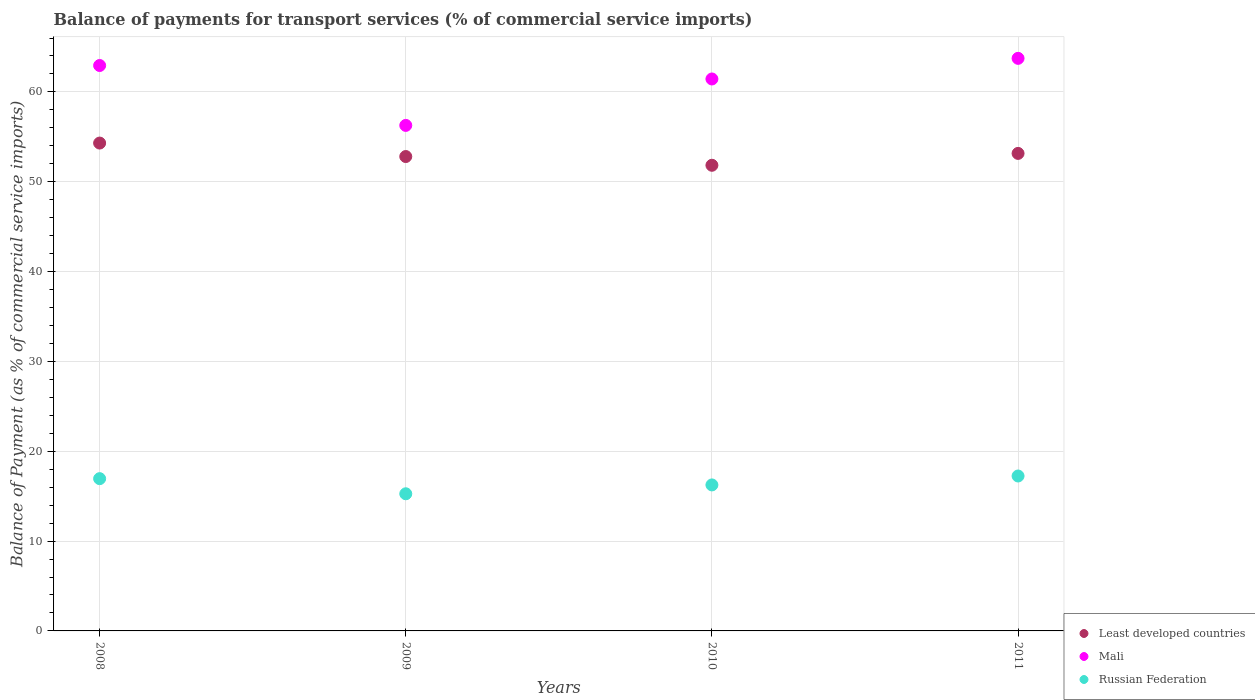What is the balance of payments for transport services in Mali in 2008?
Your answer should be compact. 62.94. Across all years, what is the maximum balance of payments for transport services in Mali?
Make the answer very short. 63.74. Across all years, what is the minimum balance of payments for transport services in Mali?
Keep it short and to the point. 56.27. In which year was the balance of payments for transport services in Mali minimum?
Offer a very short reply. 2009. What is the total balance of payments for transport services in Least developed countries in the graph?
Provide a short and direct response. 212.1. What is the difference between the balance of payments for transport services in Mali in 2010 and that in 2011?
Give a very brief answer. -2.3. What is the difference between the balance of payments for transport services in Least developed countries in 2010 and the balance of payments for transport services in Russian Federation in 2009?
Your answer should be compact. 36.57. What is the average balance of payments for transport services in Mali per year?
Offer a terse response. 61.1. In the year 2011, what is the difference between the balance of payments for transport services in Mali and balance of payments for transport services in Least developed countries?
Keep it short and to the point. 10.58. In how many years, is the balance of payments for transport services in Russian Federation greater than 60 %?
Your answer should be compact. 0. What is the ratio of the balance of payments for transport services in Mali in 2008 to that in 2011?
Give a very brief answer. 0.99. Is the balance of payments for transport services in Least developed countries in 2008 less than that in 2009?
Your response must be concise. No. What is the difference between the highest and the second highest balance of payments for transport services in Russian Federation?
Provide a short and direct response. 0.3. What is the difference between the highest and the lowest balance of payments for transport services in Russian Federation?
Give a very brief answer. 1.98. Is it the case that in every year, the sum of the balance of payments for transport services in Least developed countries and balance of payments for transport services in Russian Federation  is greater than the balance of payments for transport services in Mali?
Keep it short and to the point. Yes. Does the balance of payments for transport services in Least developed countries monotonically increase over the years?
Your answer should be very brief. No. Is the balance of payments for transport services in Least developed countries strictly greater than the balance of payments for transport services in Russian Federation over the years?
Your answer should be compact. Yes. How many dotlines are there?
Provide a short and direct response. 3. What is the difference between two consecutive major ticks on the Y-axis?
Your answer should be compact. 10. Are the values on the major ticks of Y-axis written in scientific E-notation?
Your answer should be compact. No. Does the graph contain any zero values?
Offer a terse response. No. Does the graph contain grids?
Your answer should be compact. Yes. How many legend labels are there?
Ensure brevity in your answer.  3. How are the legend labels stacked?
Offer a terse response. Vertical. What is the title of the graph?
Ensure brevity in your answer.  Balance of payments for transport services (% of commercial service imports). Does "Cayman Islands" appear as one of the legend labels in the graph?
Ensure brevity in your answer.  No. What is the label or title of the Y-axis?
Your answer should be compact. Balance of Payment (as % of commercial service imports). What is the Balance of Payment (as % of commercial service imports) of Least developed countries in 2008?
Your answer should be compact. 54.3. What is the Balance of Payment (as % of commercial service imports) in Mali in 2008?
Provide a short and direct response. 62.94. What is the Balance of Payment (as % of commercial service imports) of Russian Federation in 2008?
Ensure brevity in your answer.  16.95. What is the Balance of Payment (as % of commercial service imports) of Least developed countries in 2009?
Provide a succinct answer. 52.81. What is the Balance of Payment (as % of commercial service imports) in Mali in 2009?
Make the answer very short. 56.27. What is the Balance of Payment (as % of commercial service imports) of Russian Federation in 2009?
Your answer should be very brief. 15.27. What is the Balance of Payment (as % of commercial service imports) of Least developed countries in 2010?
Offer a terse response. 51.83. What is the Balance of Payment (as % of commercial service imports) in Mali in 2010?
Your response must be concise. 61.44. What is the Balance of Payment (as % of commercial service imports) of Russian Federation in 2010?
Your response must be concise. 16.25. What is the Balance of Payment (as % of commercial service imports) of Least developed countries in 2011?
Offer a terse response. 53.15. What is the Balance of Payment (as % of commercial service imports) in Mali in 2011?
Your answer should be very brief. 63.74. What is the Balance of Payment (as % of commercial service imports) in Russian Federation in 2011?
Your response must be concise. 17.24. Across all years, what is the maximum Balance of Payment (as % of commercial service imports) of Least developed countries?
Offer a very short reply. 54.3. Across all years, what is the maximum Balance of Payment (as % of commercial service imports) of Mali?
Your answer should be very brief. 63.74. Across all years, what is the maximum Balance of Payment (as % of commercial service imports) in Russian Federation?
Ensure brevity in your answer.  17.24. Across all years, what is the minimum Balance of Payment (as % of commercial service imports) in Least developed countries?
Provide a succinct answer. 51.83. Across all years, what is the minimum Balance of Payment (as % of commercial service imports) of Mali?
Your answer should be compact. 56.27. Across all years, what is the minimum Balance of Payment (as % of commercial service imports) of Russian Federation?
Offer a very short reply. 15.27. What is the total Balance of Payment (as % of commercial service imports) in Least developed countries in the graph?
Offer a very short reply. 212.1. What is the total Balance of Payment (as % of commercial service imports) of Mali in the graph?
Make the answer very short. 244.38. What is the total Balance of Payment (as % of commercial service imports) of Russian Federation in the graph?
Provide a short and direct response. 65.71. What is the difference between the Balance of Payment (as % of commercial service imports) of Least developed countries in 2008 and that in 2009?
Provide a short and direct response. 1.5. What is the difference between the Balance of Payment (as % of commercial service imports) of Russian Federation in 2008 and that in 2009?
Provide a succinct answer. 1.68. What is the difference between the Balance of Payment (as % of commercial service imports) in Least developed countries in 2008 and that in 2010?
Your answer should be very brief. 2.47. What is the difference between the Balance of Payment (as % of commercial service imports) in Mali in 2008 and that in 2010?
Ensure brevity in your answer.  1.5. What is the difference between the Balance of Payment (as % of commercial service imports) in Russian Federation in 2008 and that in 2010?
Give a very brief answer. 0.7. What is the difference between the Balance of Payment (as % of commercial service imports) in Least developed countries in 2008 and that in 2011?
Your response must be concise. 1.15. What is the difference between the Balance of Payment (as % of commercial service imports) of Mali in 2008 and that in 2011?
Offer a very short reply. -0.8. What is the difference between the Balance of Payment (as % of commercial service imports) in Russian Federation in 2008 and that in 2011?
Give a very brief answer. -0.3. What is the difference between the Balance of Payment (as % of commercial service imports) of Least developed countries in 2009 and that in 2010?
Your response must be concise. 0.97. What is the difference between the Balance of Payment (as % of commercial service imports) in Mali in 2009 and that in 2010?
Offer a very short reply. -5.17. What is the difference between the Balance of Payment (as % of commercial service imports) of Russian Federation in 2009 and that in 2010?
Make the answer very short. -0.99. What is the difference between the Balance of Payment (as % of commercial service imports) of Least developed countries in 2009 and that in 2011?
Offer a very short reply. -0.35. What is the difference between the Balance of Payment (as % of commercial service imports) of Mali in 2009 and that in 2011?
Provide a succinct answer. -7.46. What is the difference between the Balance of Payment (as % of commercial service imports) of Russian Federation in 2009 and that in 2011?
Your response must be concise. -1.98. What is the difference between the Balance of Payment (as % of commercial service imports) of Least developed countries in 2010 and that in 2011?
Your answer should be very brief. -1.32. What is the difference between the Balance of Payment (as % of commercial service imports) of Mali in 2010 and that in 2011?
Offer a very short reply. -2.3. What is the difference between the Balance of Payment (as % of commercial service imports) of Russian Federation in 2010 and that in 2011?
Make the answer very short. -0.99. What is the difference between the Balance of Payment (as % of commercial service imports) of Least developed countries in 2008 and the Balance of Payment (as % of commercial service imports) of Mali in 2009?
Your response must be concise. -1.97. What is the difference between the Balance of Payment (as % of commercial service imports) of Least developed countries in 2008 and the Balance of Payment (as % of commercial service imports) of Russian Federation in 2009?
Your answer should be very brief. 39.04. What is the difference between the Balance of Payment (as % of commercial service imports) in Mali in 2008 and the Balance of Payment (as % of commercial service imports) in Russian Federation in 2009?
Provide a succinct answer. 47.67. What is the difference between the Balance of Payment (as % of commercial service imports) of Least developed countries in 2008 and the Balance of Payment (as % of commercial service imports) of Mali in 2010?
Your response must be concise. -7.13. What is the difference between the Balance of Payment (as % of commercial service imports) of Least developed countries in 2008 and the Balance of Payment (as % of commercial service imports) of Russian Federation in 2010?
Keep it short and to the point. 38.05. What is the difference between the Balance of Payment (as % of commercial service imports) of Mali in 2008 and the Balance of Payment (as % of commercial service imports) of Russian Federation in 2010?
Offer a very short reply. 46.69. What is the difference between the Balance of Payment (as % of commercial service imports) of Least developed countries in 2008 and the Balance of Payment (as % of commercial service imports) of Mali in 2011?
Your answer should be compact. -9.43. What is the difference between the Balance of Payment (as % of commercial service imports) in Least developed countries in 2008 and the Balance of Payment (as % of commercial service imports) in Russian Federation in 2011?
Provide a short and direct response. 37.06. What is the difference between the Balance of Payment (as % of commercial service imports) of Mali in 2008 and the Balance of Payment (as % of commercial service imports) of Russian Federation in 2011?
Keep it short and to the point. 45.69. What is the difference between the Balance of Payment (as % of commercial service imports) of Least developed countries in 2009 and the Balance of Payment (as % of commercial service imports) of Mali in 2010?
Give a very brief answer. -8.63. What is the difference between the Balance of Payment (as % of commercial service imports) in Least developed countries in 2009 and the Balance of Payment (as % of commercial service imports) in Russian Federation in 2010?
Make the answer very short. 36.55. What is the difference between the Balance of Payment (as % of commercial service imports) of Mali in 2009 and the Balance of Payment (as % of commercial service imports) of Russian Federation in 2010?
Provide a short and direct response. 40.02. What is the difference between the Balance of Payment (as % of commercial service imports) of Least developed countries in 2009 and the Balance of Payment (as % of commercial service imports) of Mali in 2011?
Provide a short and direct response. -10.93. What is the difference between the Balance of Payment (as % of commercial service imports) of Least developed countries in 2009 and the Balance of Payment (as % of commercial service imports) of Russian Federation in 2011?
Offer a very short reply. 35.56. What is the difference between the Balance of Payment (as % of commercial service imports) of Mali in 2009 and the Balance of Payment (as % of commercial service imports) of Russian Federation in 2011?
Your answer should be compact. 39.03. What is the difference between the Balance of Payment (as % of commercial service imports) in Least developed countries in 2010 and the Balance of Payment (as % of commercial service imports) in Mali in 2011?
Make the answer very short. -11.9. What is the difference between the Balance of Payment (as % of commercial service imports) of Least developed countries in 2010 and the Balance of Payment (as % of commercial service imports) of Russian Federation in 2011?
Give a very brief answer. 34.59. What is the difference between the Balance of Payment (as % of commercial service imports) of Mali in 2010 and the Balance of Payment (as % of commercial service imports) of Russian Federation in 2011?
Offer a very short reply. 44.19. What is the average Balance of Payment (as % of commercial service imports) of Least developed countries per year?
Ensure brevity in your answer.  53.02. What is the average Balance of Payment (as % of commercial service imports) of Mali per year?
Your answer should be compact. 61.1. What is the average Balance of Payment (as % of commercial service imports) of Russian Federation per year?
Offer a very short reply. 16.43. In the year 2008, what is the difference between the Balance of Payment (as % of commercial service imports) of Least developed countries and Balance of Payment (as % of commercial service imports) of Mali?
Your response must be concise. -8.63. In the year 2008, what is the difference between the Balance of Payment (as % of commercial service imports) in Least developed countries and Balance of Payment (as % of commercial service imports) in Russian Federation?
Provide a short and direct response. 37.36. In the year 2008, what is the difference between the Balance of Payment (as % of commercial service imports) of Mali and Balance of Payment (as % of commercial service imports) of Russian Federation?
Keep it short and to the point. 45.99. In the year 2009, what is the difference between the Balance of Payment (as % of commercial service imports) in Least developed countries and Balance of Payment (as % of commercial service imports) in Mali?
Ensure brevity in your answer.  -3.47. In the year 2009, what is the difference between the Balance of Payment (as % of commercial service imports) in Least developed countries and Balance of Payment (as % of commercial service imports) in Russian Federation?
Your response must be concise. 37.54. In the year 2009, what is the difference between the Balance of Payment (as % of commercial service imports) in Mali and Balance of Payment (as % of commercial service imports) in Russian Federation?
Your answer should be very brief. 41.01. In the year 2010, what is the difference between the Balance of Payment (as % of commercial service imports) of Least developed countries and Balance of Payment (as % of commercial service imports) of Mali?
Provide a short and direct response. -9.61. In the year 2010, what is the difference between the Balance of Payment (as % of commercial service imports) in Least developed countries and Balance of Payment (as % of commercial service imports) in Russian Federation?
Offer a very short reply. 35.58. In the year 2010, what is the difference between the Balance of Payment (as % of commercial service imports) in Mali and Balance of Payment (as % of commercial service imports) in Russian Federation?
Ensure brevity in your answer.  45.19. In the year 2011, what is the difference between the Balance of Payment (as % of commercial service imports) in Least developed countries and Balance of Payment (as % of commercial service imports) in Mali?
Provide a short and direct response. -10.58. In the year 2011, what is the difference between the Balance of Payment (as % of commercial service imports) of Least developed countries and Balance of Payment (as % of commercial service imports) of Russian Federation?
Provide a short and direct response. 35.91. In the year 2011, what is the difference between the Balance of Payment (as % of commercial service imports) in Mali and Balance of Payment (as % of commercial service imports) in Russian Federation?
Your answer should be very brief. 46.49. What is the ratio of the Balance of Payment (as % of commercial service imports) in Least developed countries in 2008 to that in 2009?
Provide a short and direct response. 1.03. What is the ratio of the Balance of Payment (as % of commercial service imports) of Mali in 2008 to that in 2009?
Make the answer very short. 1.12. What is the ratio of the Balance of Payment (as % of commercial service imports) of Russian Federation in 2008 to that in 2009?
Provide a succinct answer. 1.11. What is the ratio of the Balance of Payment (as % of commercial service imports) in Least developed countries in 2008 to that in 2010?
Your answer should be very brief. 1.05. What is the ratio of the Balance of Payment (as % of commercial service imports) in Mali in 2008 to that in 2010?
Your answer should be very brief. 1.02. What is the ratio of the Balance of Payment (as % of commercial service imports) of Russian Federation in 2008 to that in 2010?
Your answer should be compact. 1.04. What is the ratio of the Balance of Payment (as % of commercial service imports) of Least developed countries in 2008 to that in 2011?
Your response must be concise. 1.02. What is the ratio of the Balance of Payment (as % of commercial service imports) in Mali in 2008 to that in 2011?
Provide a short and direct response. 0.99. What is the ratio of the Balance of Payment (as % of commercial service imports) of Russian Federation in 2008 to that in 2011?
Your answer should be compact. 0.98. What is the ratio of the Balance of Payment (as % of commercial service imports) in Least developed countries in 2009 to that in 2010?
Your answer should be compact. 1.02. What is the ratio of the Balance of Payment (as % of commercial service imports) of Mali in 2009 to that in 2010?
Make the answer very short. 0.92. What is the ratio of the Balance of Payment (as % of commercial service imports) of Russian Federation in 2009 to that in 2010?
Ensure brevity in your answer.  0.94. What is the ratio of the Balance of Payment (as % of commercial service imports) of Mali in 2009 to that in 2011?
Your response must be concise. 0.88. What is the ratio of the Balance of Payment (as % of commercial service imports) of Russian Federation in 2009 to that in 2011?
Make the answer very short. 0.89. What is the ratio of the Balance of Payment (as % of commercial service imports) of Least developed countries in 2010 to that in 2011?
Make the answer very short. 0.98. What is the ratio of the Balance of Payment (as % of commercial service imports) in Russian Federation in 2010 to that in 2011?
Your answer should be very brief. 0.94. What is the difference between the highest and the second highest Balance of Payment (as % of commercial service imports) of Least developed countries?
Offer a very short reply. 1.15. What is the difference between the highest and the second highest Balance of Payment (as % of commercial service imports) of Mali?
Provide a short and direct response. 0.8. What is the difference between the highest and the second highest Balance of Payment (as % of commercial service imports) in Russian Federation?
Provide a short and direct response. 0.3. What is the difference between the highest and the lowest Balance of Payment (as % of commercial service imports) of Least developed countries?
Your response must be concise. 2.47. What is the difference between the highest and the lowest Balance of Payment (as % of commercial service imports) of Mali?
Your response must be concise. 7.46. What is the difference between the highest and the lowest Balance of Payment (as % of commercial service imports) in Russian Federation?
Offer a terse response. 1.98. 